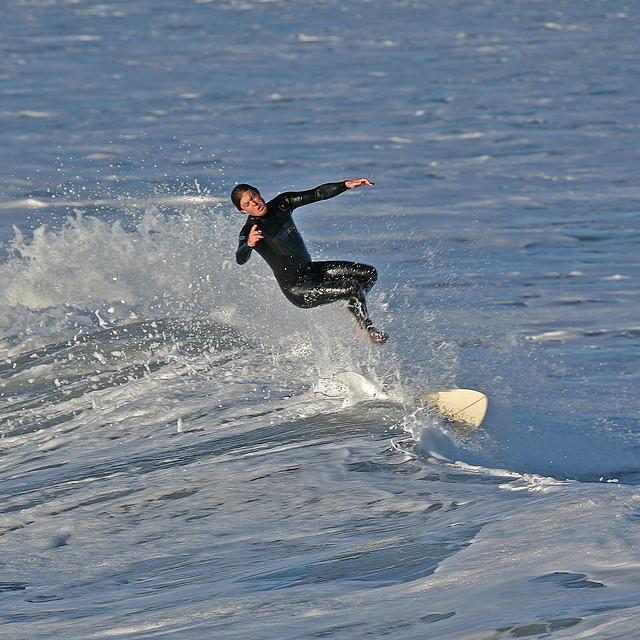What is the color of the water?
Be succinct. Blue. Did he lose his surfboard?
Be succinct. Yes. Is the man wearing a wetsuit?
Concise answer only. Yes. 